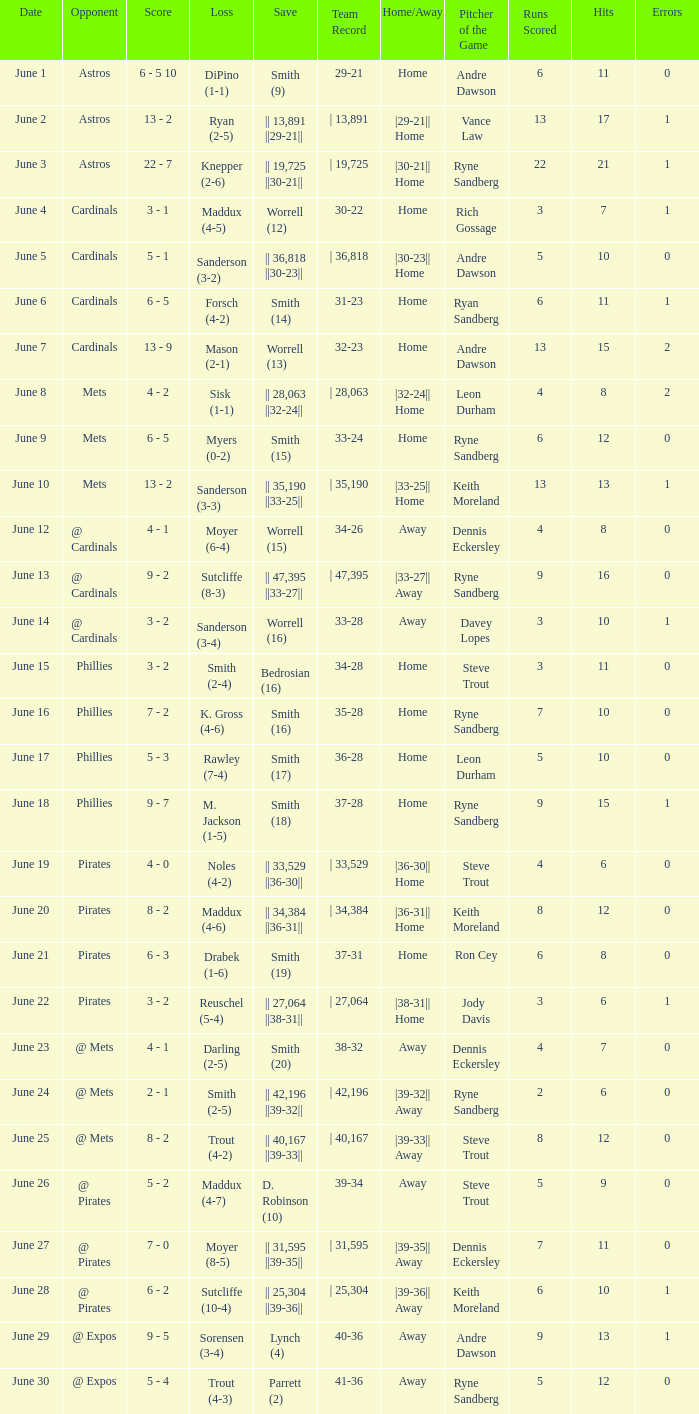On which day did the Chicago Cubs have a loss of trout (4-2)? June 25. 